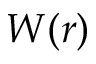<formula> <loc_0><loc_0><loc_500><loc_500>W ( r )</formula> 